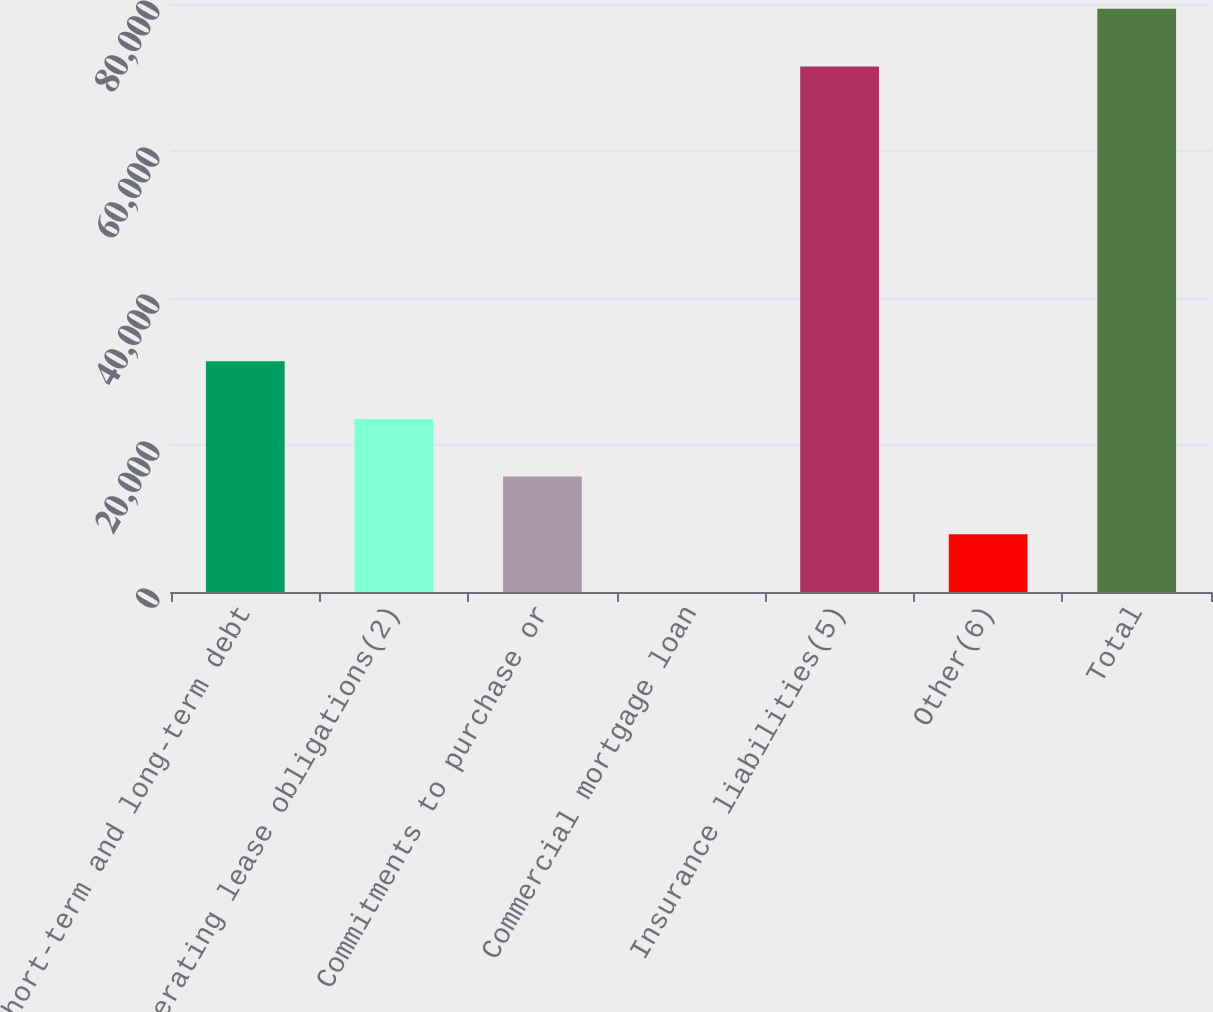Convert chart to OTSL. <chart><loc_0><loc_0><loc_500><loc_500><bar_chart><fcel>Short-term and long-term debt<fcel>Operating lease obligations(2)<fcel>Commitments to purchase or<fcel>Commercial mortgage loan<fcel>Insurance liabilities(5)<fcel>Other(6)<fcel>Total<nl><fcel>31398.6<fcel>23549.2<fcel>15699.8<fcel>1<fcel>71500<fcel>7850.4<fcel>79349.4<nl></chart> 